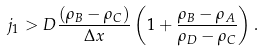<formula> <loc_0><loc_0><loc_500><loc_500>j _ { 1 } > D \frac { ( \rho _ { B } - \rho _ { C } ) } { \Delta x } \left ( 1 + \frac { \rho _ { B } - \rho _ { A } } { \rho _ { D } - \rho _ { C } } \right ) .</formula> 